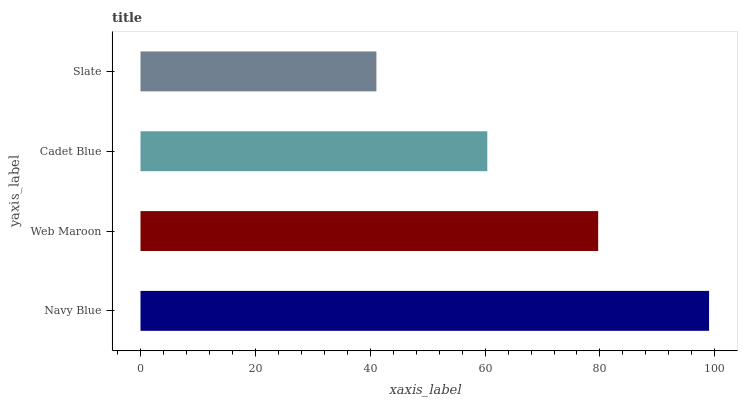Is Slate the minimum?
Answer yes or no. Yes. Is Navy Blue the maximum?
Answer yes or no. Yes. Is Web Maroon the minimum?
Answer yes or no. No. Is Web Maroon the maximum?
Answer yes or no. No. Is Navy Blue greater than Web Maroon?
Answer yes or no. Yes. Is Web Maroon less than Navy Blue?
Answer yes or no. Yes. Is Web Maroon greater than Navy Blue?
Answer yes or no. No. Is Navy Blue less than Web Maroon?
Answer yes or no. No. Is Web Maroon the high median?
Answer yes or no. Yes. Is Cadet Blue the low median?
Answer yes or no. Yes. Is Cadet Blue the high median?
Answer yes or no. No. Is Web Maroon the low median?
Answer yes or no. No. 